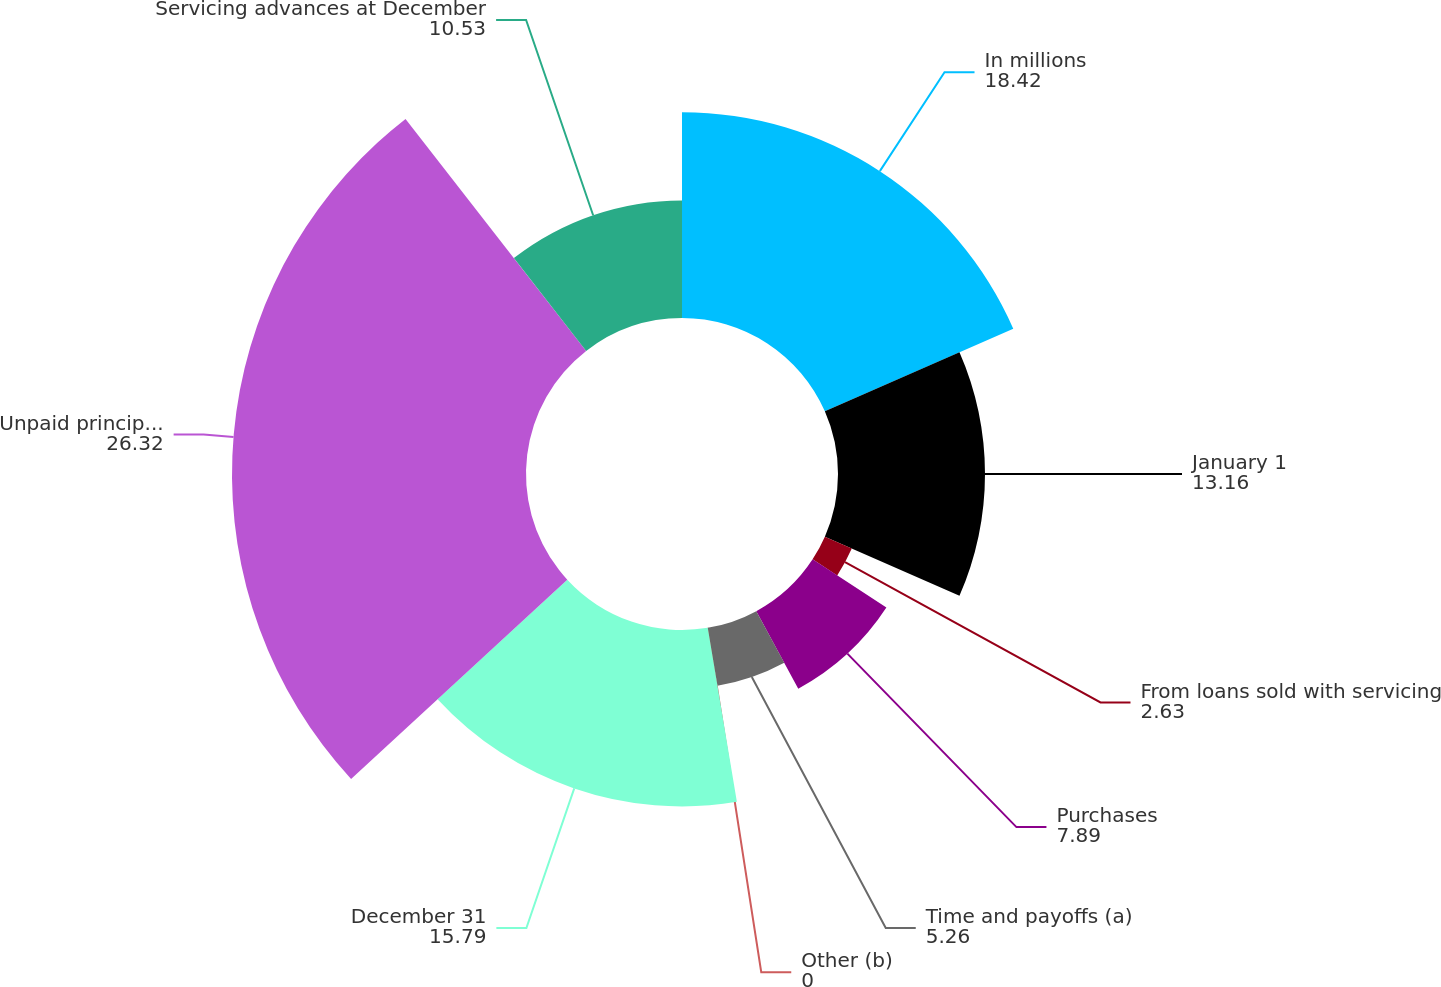Convert chart. <chart><loc_0><loc_0><loc_500><loc_500><pie_chart><fcel>In millions<fcel>January 1<fcel>From loans sold with servicing<fcel>Purchases<fcel>Time and payoffs (a)<fcel>Other (b)<fcel>December 31<fcel>Unpaid principal balance of<fcel>Servicing advances at December<nl><fcel>18.42%<fcel>13.16%<fcel>2.63%<fcel>7.89%<fcel>5.26%<fcel>0.0%<fcel>15.79%<fcel>26.32%<fcel>10.53%<nl></chart> 